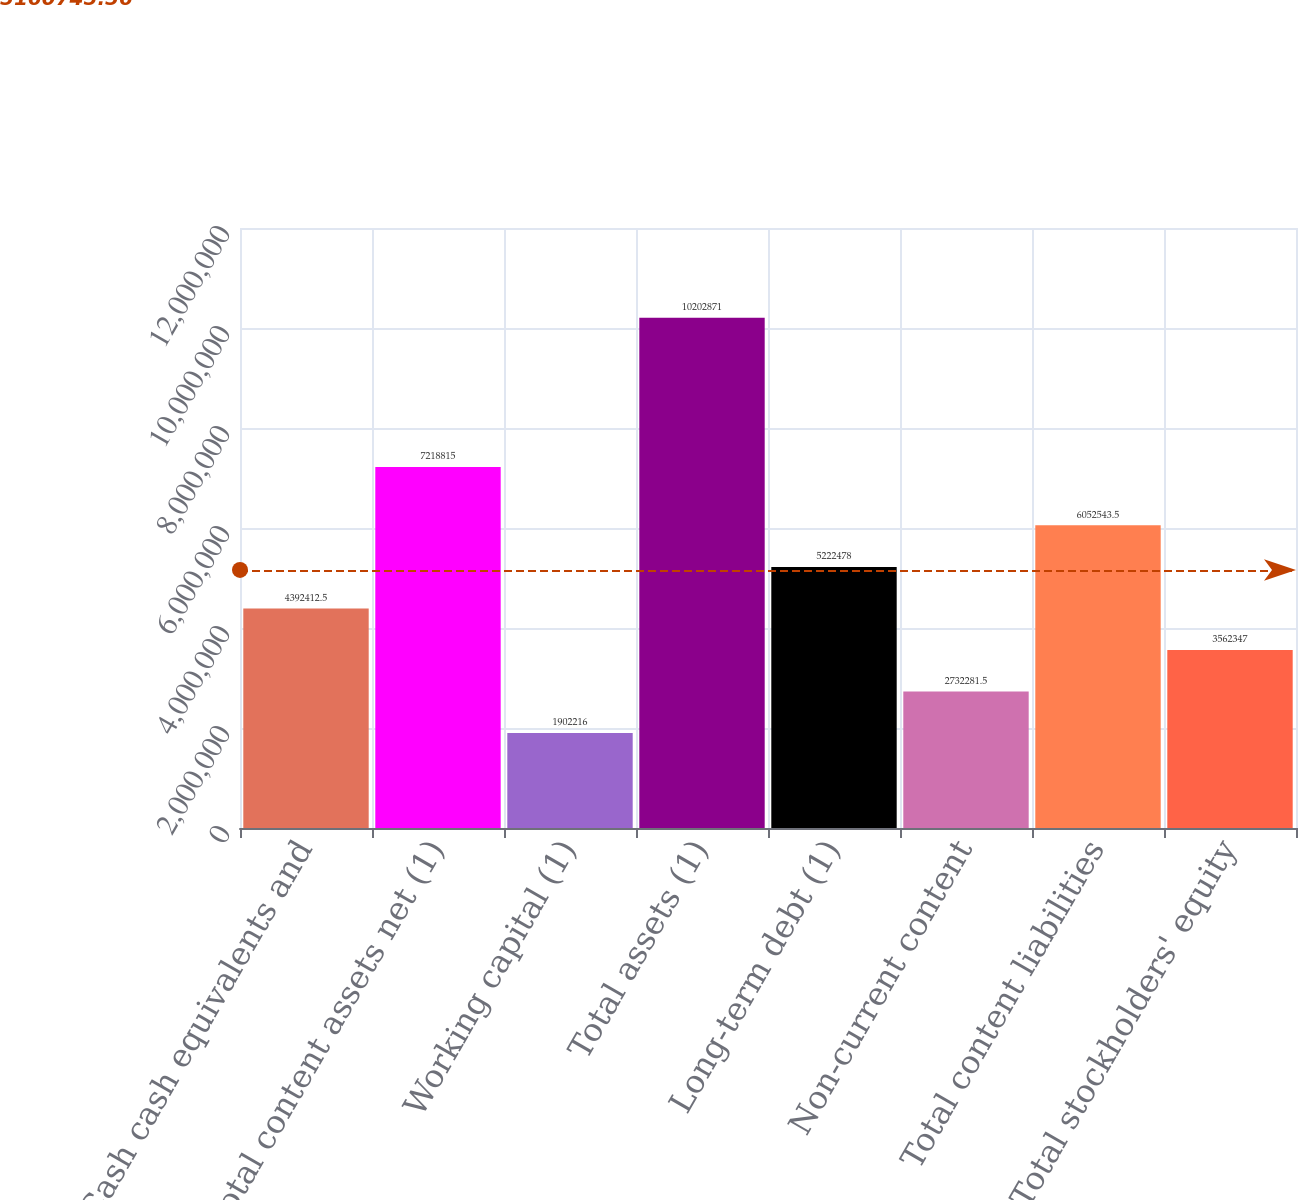Convert chart to OTSL. <chart><loc_0><loc_0><loc_500><loc_500><bar_chart><fcel>Cash cash equivalents and<fcel>Total content assets net (1)<fcel>Working capital (1)<fcel>Total assets (1)<fcel>Long-term debt (1)<fcel>Non-current content<fcel>Total content liabilities<fcel>Total stockholders' equity<nl><fcel>4.39241e+06<fcel>7.21882e+06<fcel>1.90222e+06<fcel>1.02029e+07<fcel>5.22248e+06<fcel>2.73228e+06<fcel>6.05254e+06<fcel>3.56235e+06<nl></chart> 